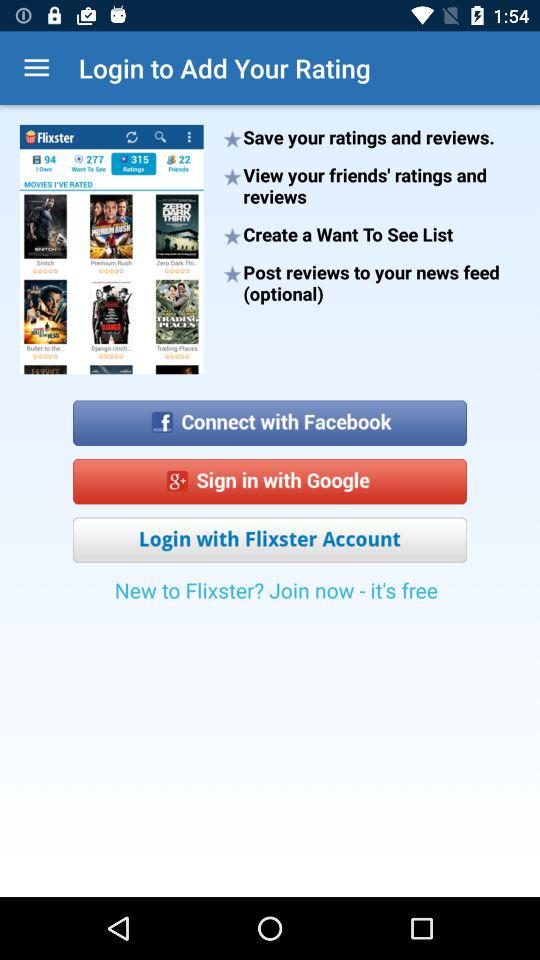How can we sign in? You can sign in with "Google". 